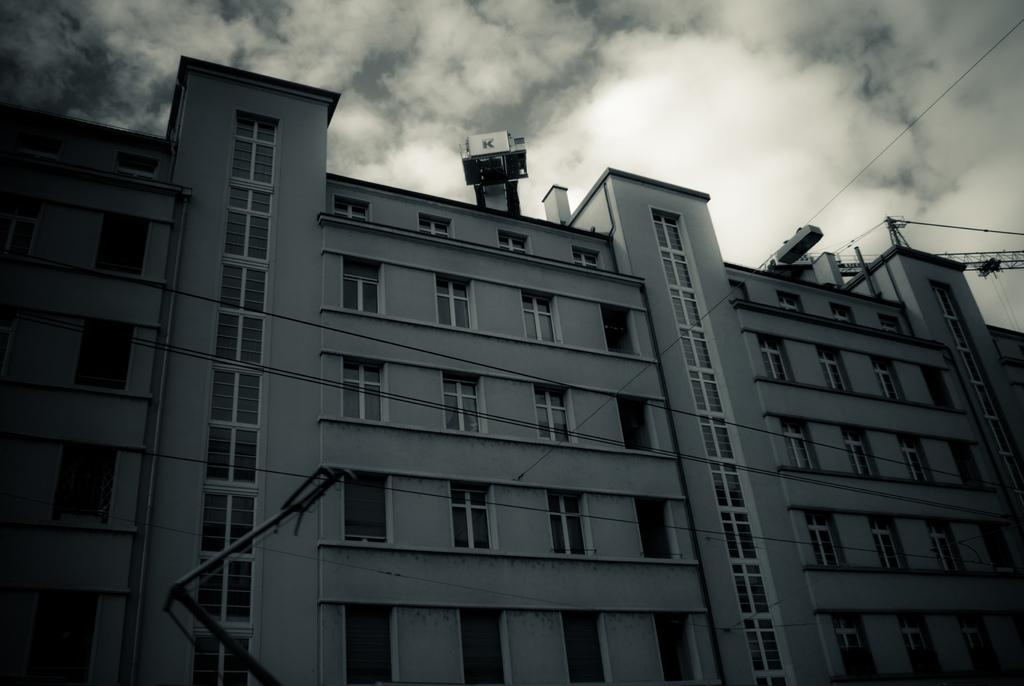What is the main structure visible in the image? There is a building in the image. How would you describe the color of the sky in the background? The sky in the background is gray and white in color. Can you see a roll of paper towels in the image? There is no roll of paper towels present in the image. What park is visible in the background of the image? There is no park visible in the image; it only features a building and the sky. 